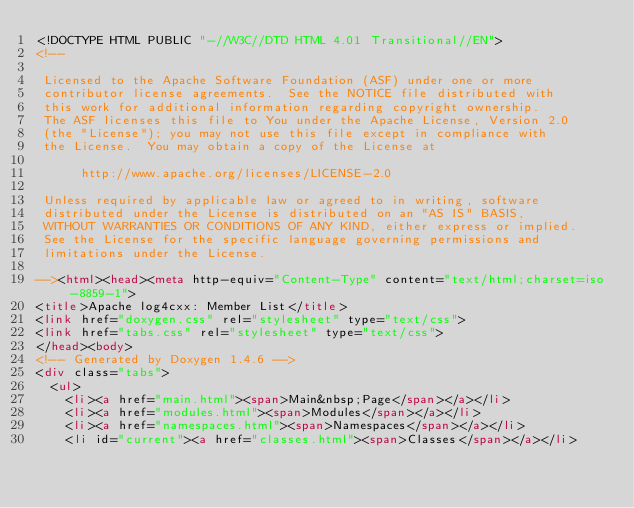Convert code to text. <code><loc_0><loc_0><loc_500><loc_500><_HTML_><!DOCTYPE HTML PUBLIC "-//W3C//DTD HTML 4.01 Transitional//EN">
<!--

 Licensed to the Apache Software Foundation (ASF) under one or more
 contributor license agreements.  See the NOTICE file distributed with
 this work for additional information regarding copyright ownership.
 The ASF licenses this file to You under the Apache License, Version 2.0
 (the "License"); you may not use this file except in compliance with
 the License.  You may obtain a copy of the License at

      http://www.apache.org/licenses/LICENSE-2.0

 Unless required by applicable law or agreed to in writing, software
 distributed under the License is distributed on an "AS IS" BASIS,
 WITHOUT WARRANTIES OR CONDITIONS OF ANY KIND, either express or implied.
 See the License for the specific language governing permissions and
 limitations under the License.

--><html><head><meta http-equiv="Content-Type" content="text/html;charset=iso-8859-1">
<title>Apache log4cxx: Member List</title>
<link href="doxygen.css" rel="stylesheet" type="text/css">
<link href="tabs.css" rel="stylesheet" type="text/css">
</head><body>
<!-- Generated by Doxygen 1.4.6 -->
<div class="tabs">
  <ul>
    <li><a href="main.html"><span>Main&nbsp;Page</span></a></li>
    <li><a href="modules.html"><span>Modules</span></a></li>
    <li><a href="namespaces.html"><span>Namespaces</span></a></li>
    <li id="current"><a href="classes.html"><span>Classes</span></a></li></code> 